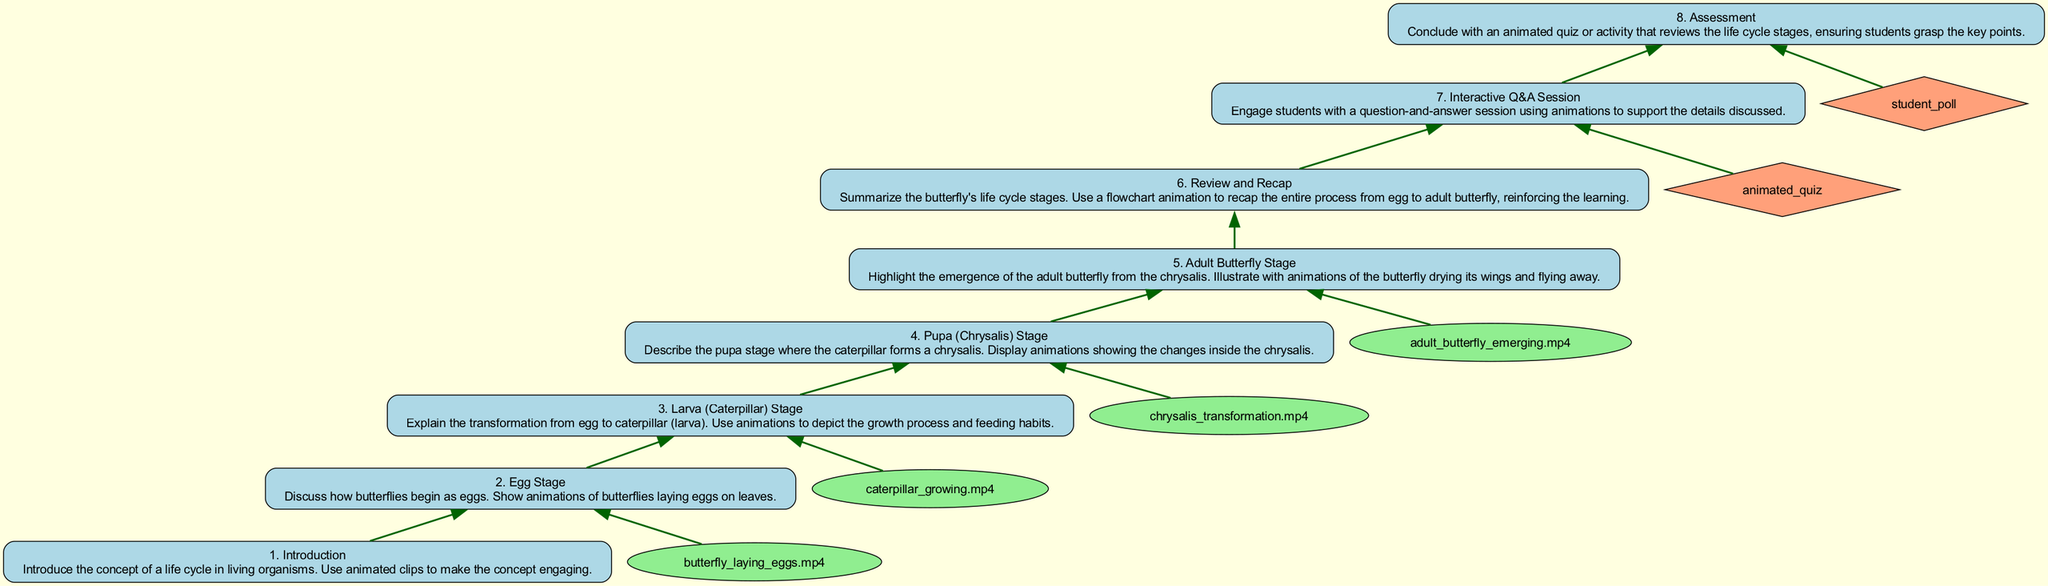What is the first step in the life cycle of a butterfly? The first step in the flow chart is labeled "Introduction," which introduces the concept of a life cycle in living organisms. The diagram flows from the bottom to the top, and this is the foundational stage of the lesson plan.
Answer: Introduction How many main stages are there in the butterfly's life cycle? The diagram has a clearly defined structure with five main stages (egg, larva, pupa, adult butterfly, review), so the answer is derived by counting these stages in the flow from the "Introduction" to the "Assessment."
Answer: Five What stage follows the larva (caterpillar) stage? In the diagram, the stage that directly follows "Larva (Caterpillar) Stage" is the "Pupa (Chrysalis) Stage." This can be determined by looking at the progression from one step to the next in the flow chart.
Answer: Pupa (Chrysalis) Stage What visual elements are used in the assessment step? The assessment step includes an "animated quiz" as specified under the visual elements. The information is gathered by identifying the interactive tools listed in the diagram that are connected to specific steps.
Answer: Animated quiz Which step includes an interactive Q&A session? The diagram clearly identifies “Interactive Q&A Session” as step 7, showing its placement and importance in the instructional flow. This can be confirmed by looking at the step labels as they ascend from bottom to top.
Answer: Interactive Q&A Session Explain the relationship between the "Adult Butterfly Stage" and the animations in the diagram. The "Adult Butterfly Stage" is related to the specific animation titled "adult_butterfly_emerging.mp4", which visually represents this stage and creates an engaging learning experience. The flow chart connects the stage directly to the animation, highlighting its importance in understanding this life cycle component.
Answer: Adult butterfly emerging.mp4 What is the last activity in the lesson plan? The final step of the lesson plan indicated in the flow chart is "Assessment," which concludes with an animated quiz or activity. This is determined by following the flow to the top of the chart, identifying the concluding activities that reinforce learning.
Answer: Assessment What color represents the nodes in the visual elements of the flow chart? The visual elements of the flow chart use a light green color for the nodes that depict animations. This can be confirmed by checking the attributes set for the node shape in the diagram.
Answer: Light green 